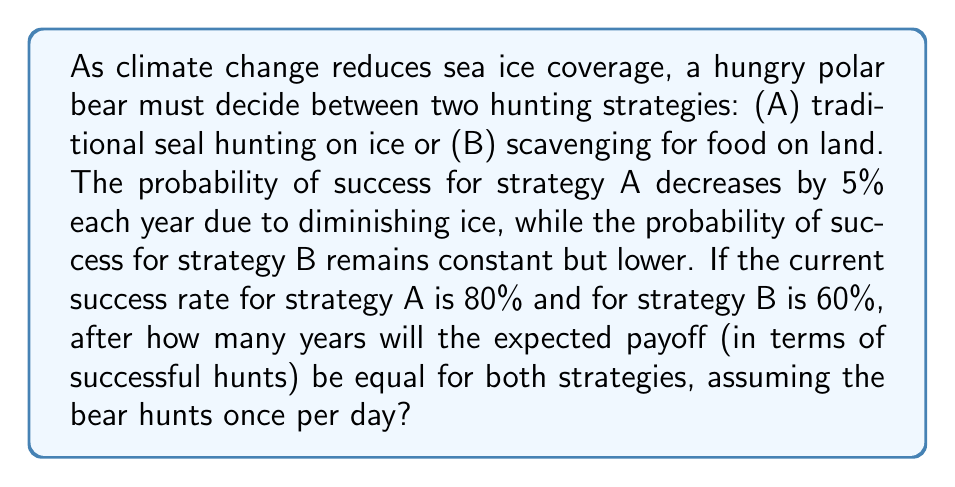Solve this math problem. Let's approach this step-by-step:

1) Let $x$ be the number of years from now.

2) The success rate for strategy A after $x$ years will be:
   $P(A) = 0.80 - 0.05x$

3) The success rate for strategy B remains constant:
   $P(B) = 0.60$

4) We want to find when these are equal:
   $0.80 - 0.05x = 0.60$

5) Solving this equation:
   $-0.05x = -0.20$
   $x = 4$

6) To verify, let's calculate the expected number of successful hunts per year for each strategy after 4 years:

   Strategy A: $365 * (0.80 - 0.05*4) = 365 * 0.60 = 219$ successful hunts
   Strategy B: $365 * 0.60 = 219$ successful hunts

7) Therefore, after 4 years, both strategies have the same expected payoff.

This game-theoretic scenario demonstrates how climate change could alter the optimal hunting strategy for polar bears over time. As the traditional hunting grounds (sea ice) become less reliable, alternative strategies become relatively more attractive, even if they are initially less productive.
Answer: The expected payoff for both hunting strategies will be equal after 4 years. 